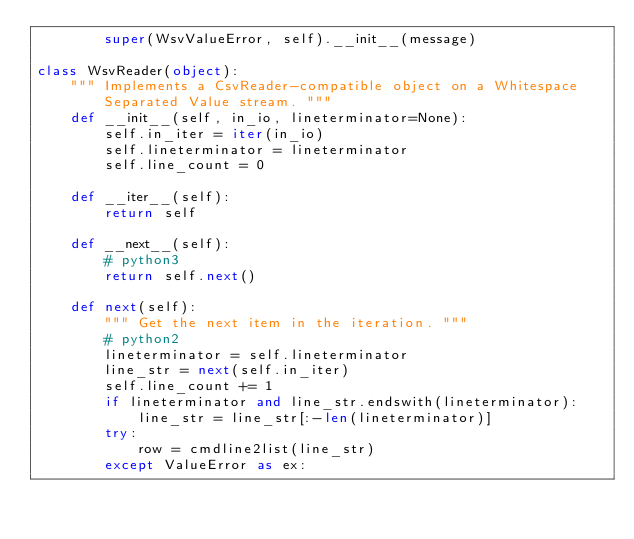<code> <loc_0><loc_0><loc_500><loc_500><_Python_>        super(WsvValueError, self).__init__(message)

class WsvReader(object):
    """ Implements a CsvReader-compatible object on a Whitespace Separated Value stream. """
    def __init__(self, in_io, lineterminator=None):
        self.in_iter = iter(in_io)
        self.lineterminator = lineterminator
        self.line_count = 0

    def __iter__(self):
        return self

    def __next__(self):
        # python3
        return self.next()

    def next(self):
        """ Get the next item in the iteration. """
        # python2
        lineterminator = self.lineterminator
        line_str = next(self.in_iter)
        self.line_count += 1
        if lineterminator and line_str.endswith(lineterminator):
            line_str = line_str[:-len(lineterminator)]
        try:
            row = cmdline2list(line_str)
        except ValueError as ex:</code> 